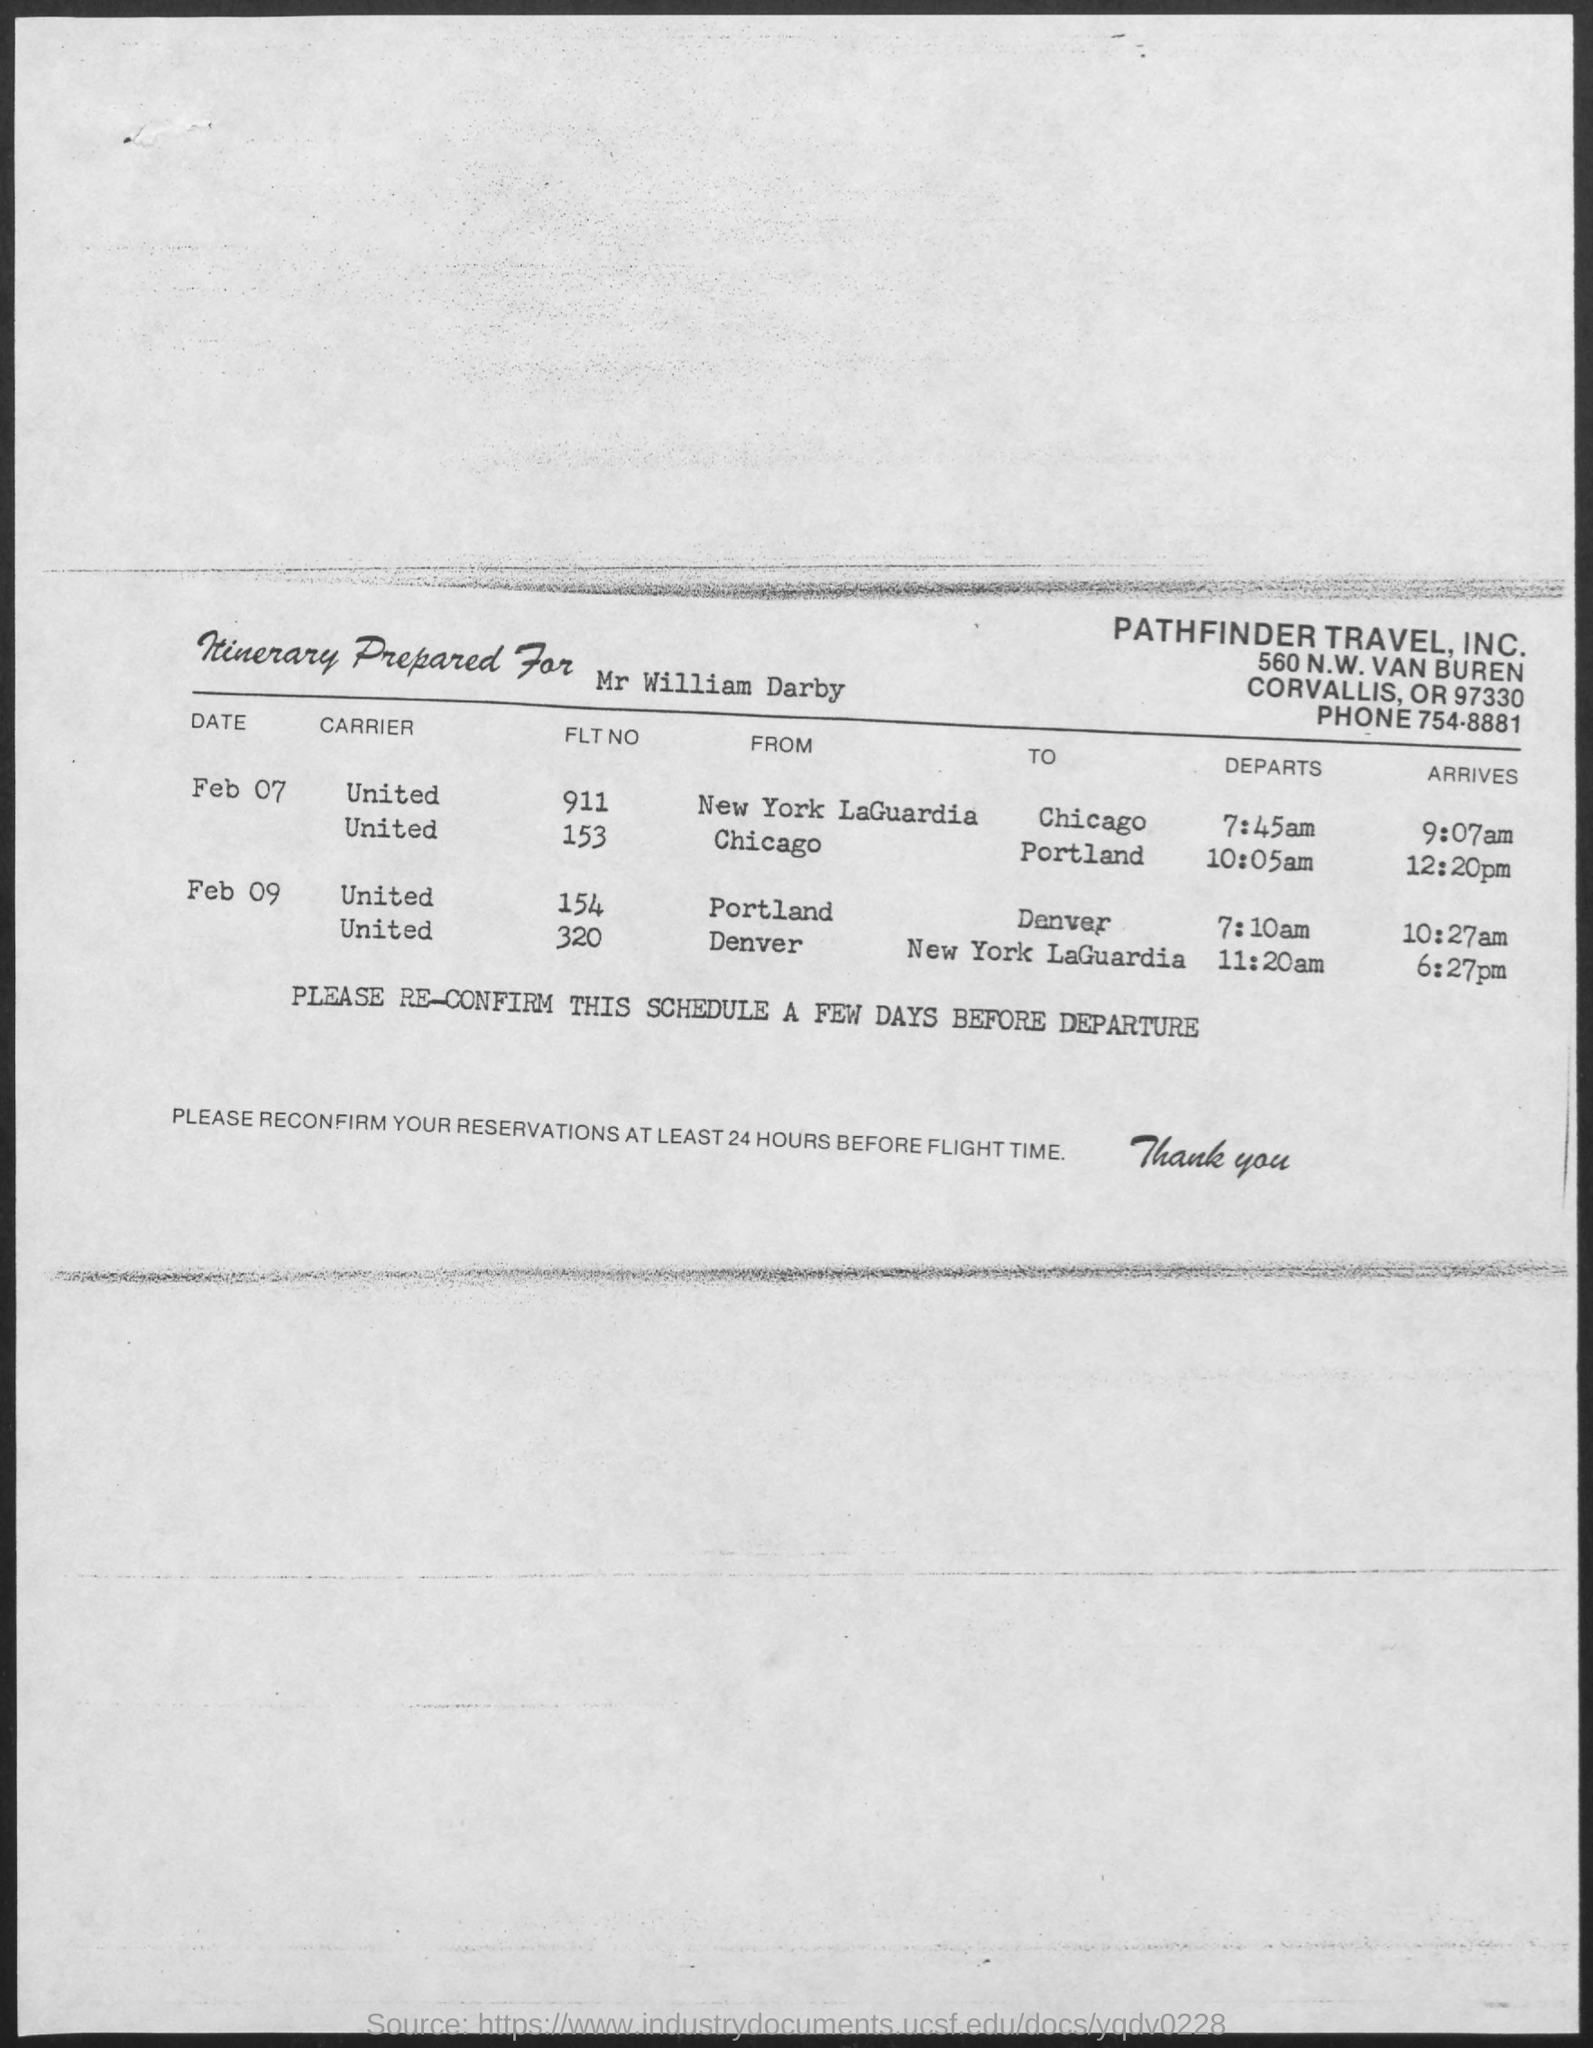What is the Flight number from Portland to Denver on Feb 09,7:10 am?
Provide a short and direct response. 154. What is the phone number mentioned in the document?
Offer a terse response. 754-8881. 